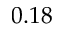Convert formula to latex. <formula><loc_0><loc_0><loc_500><loc_500>0 . 1 8</formula> 